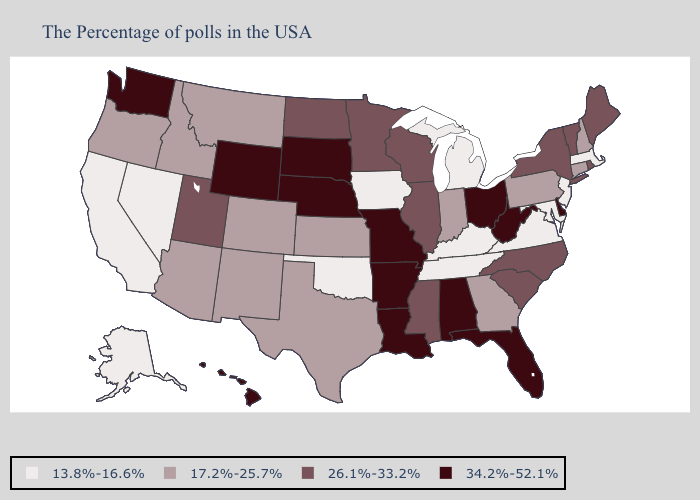What is the value of Wisconsin?
Write a very short answer. 26.1%-33.2%. Among the states that border Tennessee , which have the lowest value?
Quick response, please. Virginia, Kentucky. Name the states that have a value in the range 17.2%-25.7%?
Concise answer only. New Hampshire, Connecticut, Pennsylvania, Georgia, Indiana, Kansas, Texas, Colorado, New Mexico, Montana, Arizona, Idaho, Oregon. Does the first symbol in the legend represent the smallest category?
Keep it brief. Yes. Name the states that have a value in the range 26.1%-33.2%?
Short answer required. Maine, Rhode Island, Vermont, New York, North Carolina, South Carolina, Wisconsin, Illinois, Mississippi, Minnesota, North Dakota, Utah. Does Alabama have the highest value in the USA?
Write a very short answer. Yes. Among the states that border Georgia , does South Carolina have the highest value?
Short answer required. No. Does California have the highest value in the West?
Be succinct. No. Does Ohio have the highest value in the MidWest?
Write a very short answer. Yes. Name the states that have a value in the range 13.8%-16.6%?
Concise answer only. Massachusetts, New Jersey, Maryland, Virginia, Michigan, Kentucky, Tennessee, Iowa, Oklahoma, Nevada, California, Alaska. What is the value of Washington?
Short answer required. 34.2%-52.1%. Which states have the highest value in the USA?
Be succinct. Delaware, West Virginia, Ohio, Florida, Alabama, Louisiana, Missouri, Arkansas, Nebraska, South Dakota, Wyoming, Washington, Hawaii. Which states have the lowest value in the USA?
Answer briefly. Massachusetts, New Jersey, Maryland, Virginia, Michigan, Kentucky, Tennessee, Iowa, Oklahoma, Nevada, California, Alaska. Among the states that border Ohio , does Kentucky have the lowest value?
Concise answer only. Yes. Name the states that have a value in the range 26.1%-33.2%?
Give a very brief answer. Maine, Rhode Island, Vermont, New York, North Carolina, South Carolina, Wisconsin, Illinois, Mississippi, Minnesota, North Dakota, Utah. 